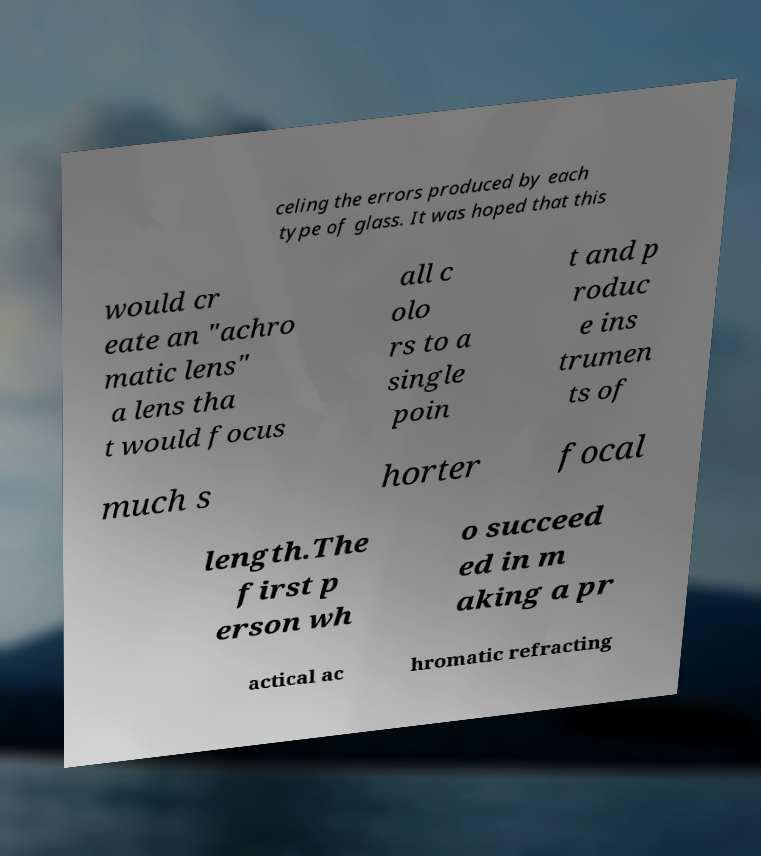Please identify and transcribe the text found in this image. celing the errors produced by each type of glass. It was hoped that this would cr eate an "achro matic lens" a lens tha t would focus all c olo rs to a single poin t and p roduc e ins trumen ts of much s horter focal length.The first p erson wh o succeed ed in m aking a pr actical ac hromatic refracting 